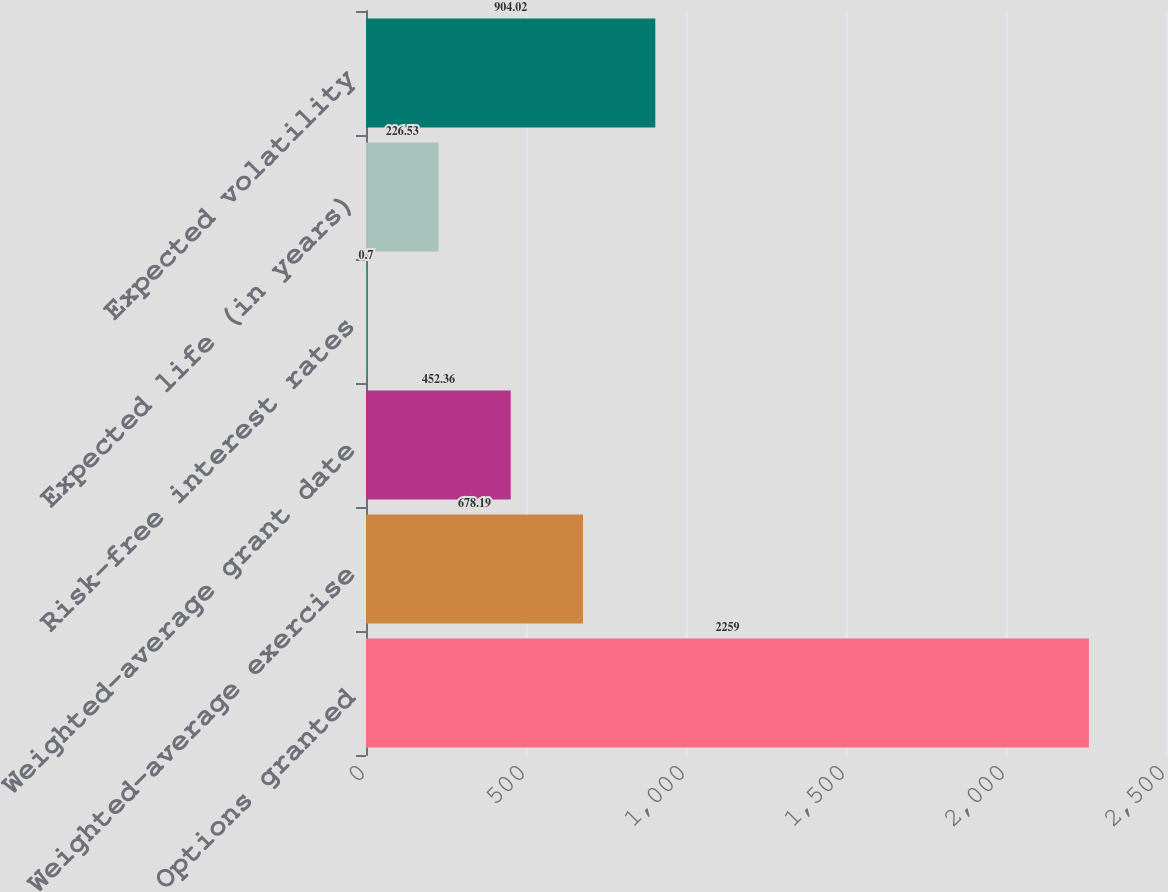<chart> <loc_0><loc_0><loc_500><loc_500><bar_chart><fcel>Options granted<fcel>Weighted-average exercise<fcel>Weighted-average grant date<fcel>Risk-free interest rates<fcel>Expected life (in years)<fcel>Expected volatility<nl><fcel>2259<fcel>678.19<fcel>452.36<fcel>0.7<fcel>226.53<fcel>904.02<nl></chart> 